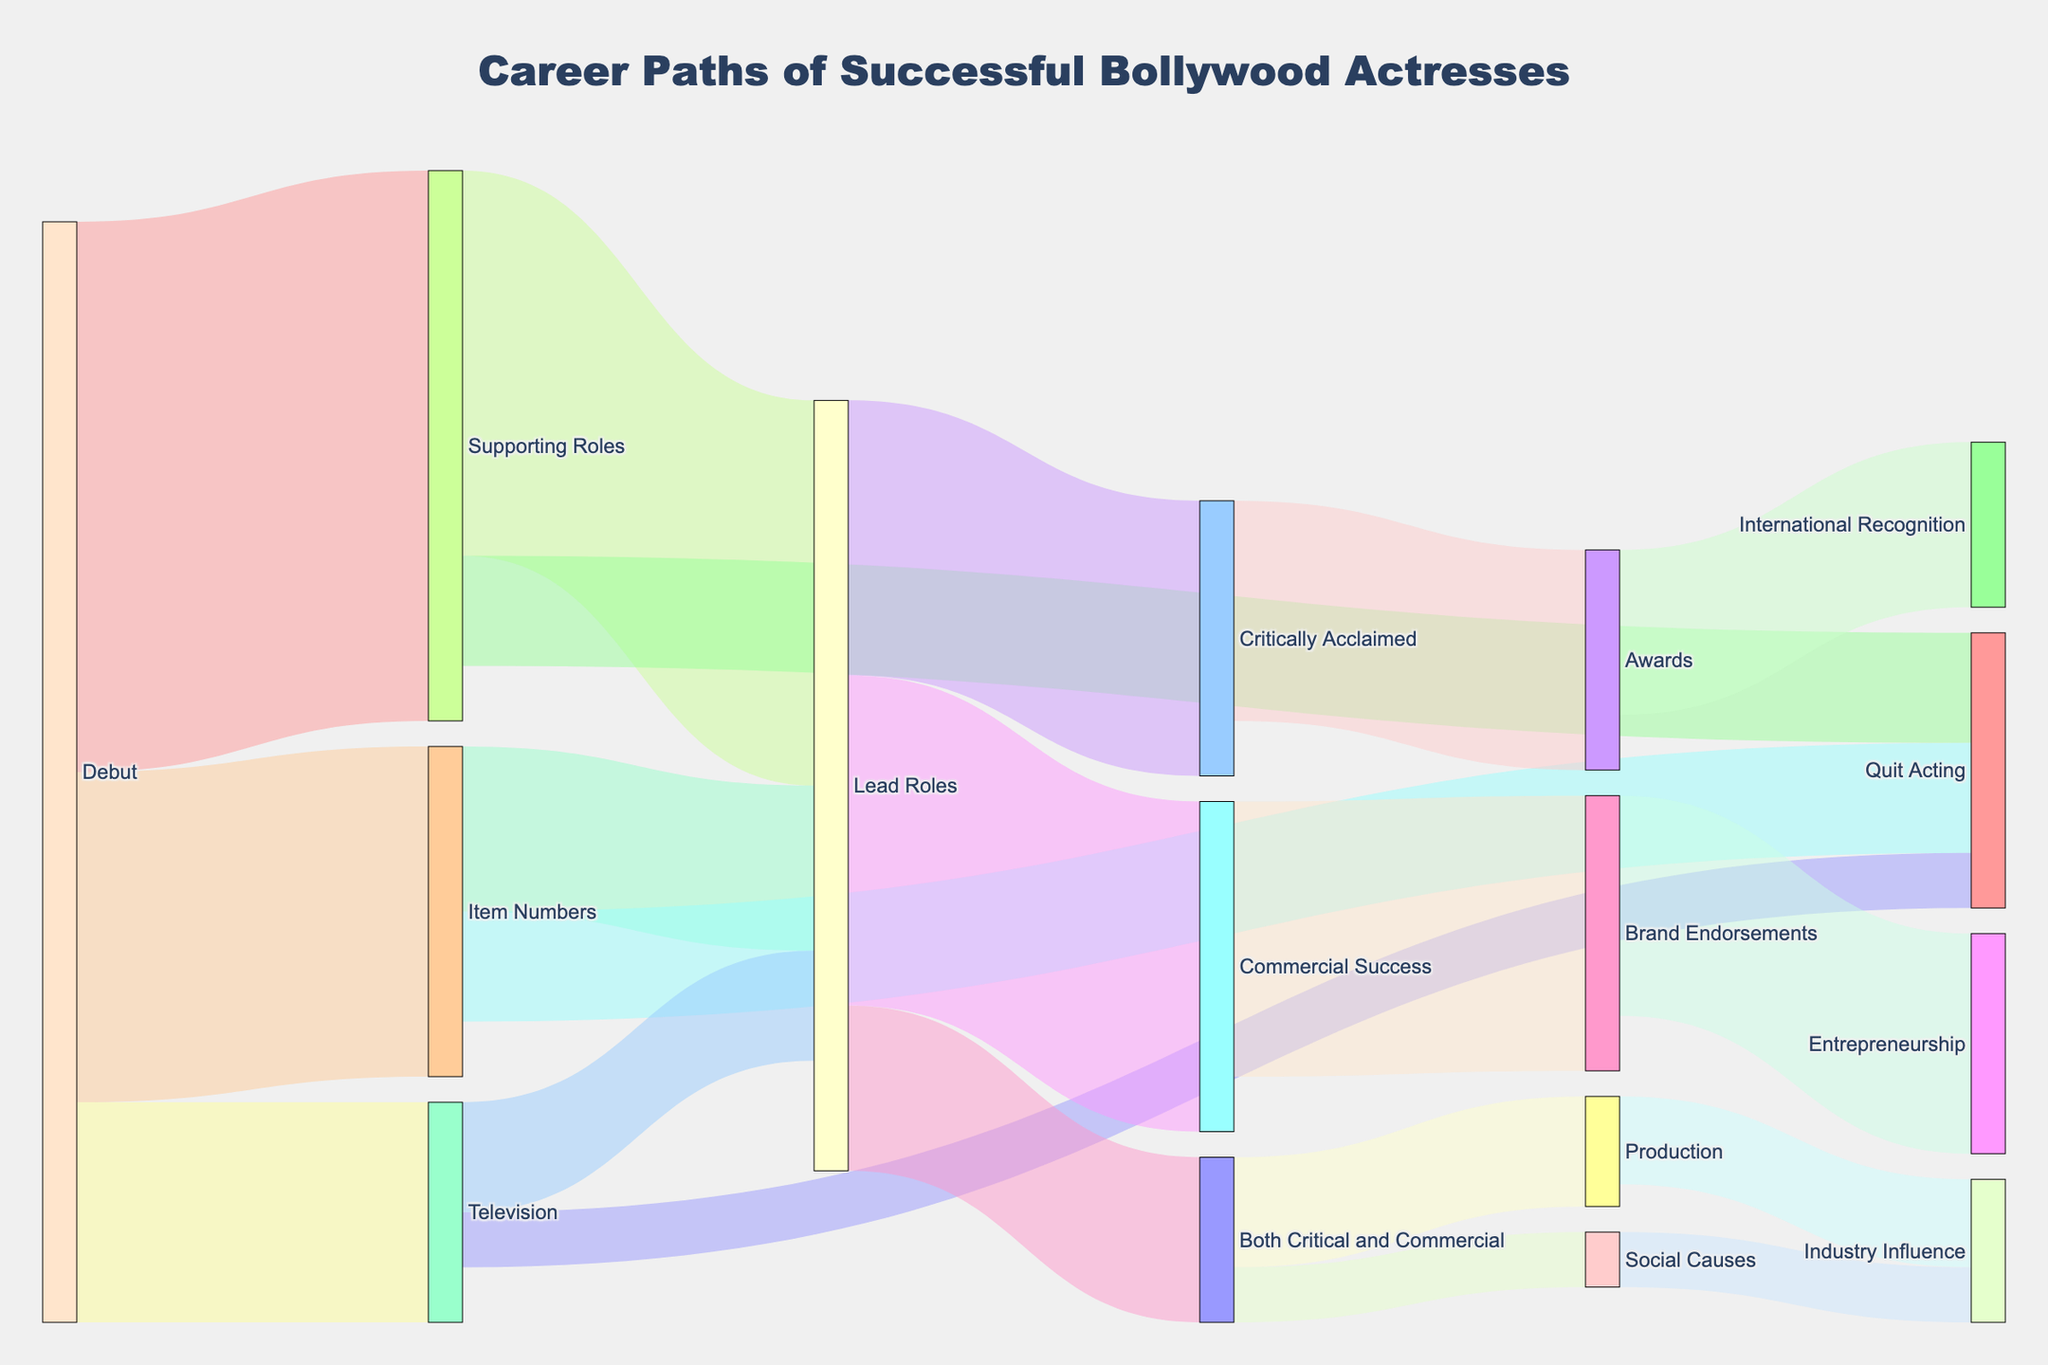What is the title of the figure? The title is displayed at the top of the figure in a larger font size. It is: "Career Paths of Successful Bollywood Actresses".
Answer: Career Paths of Successful Bollywood Actresses How many initial career paths are depicted in the Sankey diagram? Look at the first set of nodes connected directly from the 'Debut' node. There are three paths: Supporting Roles, Item Numbers, and Television.
Answer: 3 What path shows the highest number of actresses transitioning from Supporting Roles? Observe the connections from 'Supporting Roles.' The largest connection is to 'Lead Roles' with a value of 35.
Answer: Lead Roles How many actresses transitioned from Item Numbers to Lead Roles? Follow the path from 'Item Numbers' to 'Lead Roles' and observe the value, which is 15.
Answer: 15 What is the combined value of actresses quitting acting from debut roles? Sum the values of actresses quitting acting from Supporting Roles, Item Numbers, and Television. It is 10 (Supporting) + 10 (Item Numbers) + 5 (Television).
Answer: 25 What is the total number of actresses considered critically acclaimed after Lead Roles? Observe the node 'Critically Acclaimed' directly after 'Lead Roles.' The value is 25.
Answer: 25 Which path shows fewer actresses: those who gained international recognition through Awards or those who became entrepreneurs through Brand Endorsements? Compare the values of 'International Recognition' and 'Entrepreneurship.' 'International Recognition' has 15, while 'Entrepreneurship' has 20.
Answer: International Recognition Which career trajectory leads to influence in the industry? Follow the paths leading to 'Industry Influence'. There are two paths: one from 'Production' with 8 and one from 'Social Causes' with 5. Both lead to industry influence.
Answer: Production, Social Causes How many actresses who started with Item Numbers achieve both critical and commercial success eventually? Trace the path from 'Item Numbers' to 'Both Critical and Commercial.' The total transition first to 'Lead Roles' is 15, then to 'Both Critical and Commercial,' where it splits among other nodes totaling the same 15.
Answer: 15 